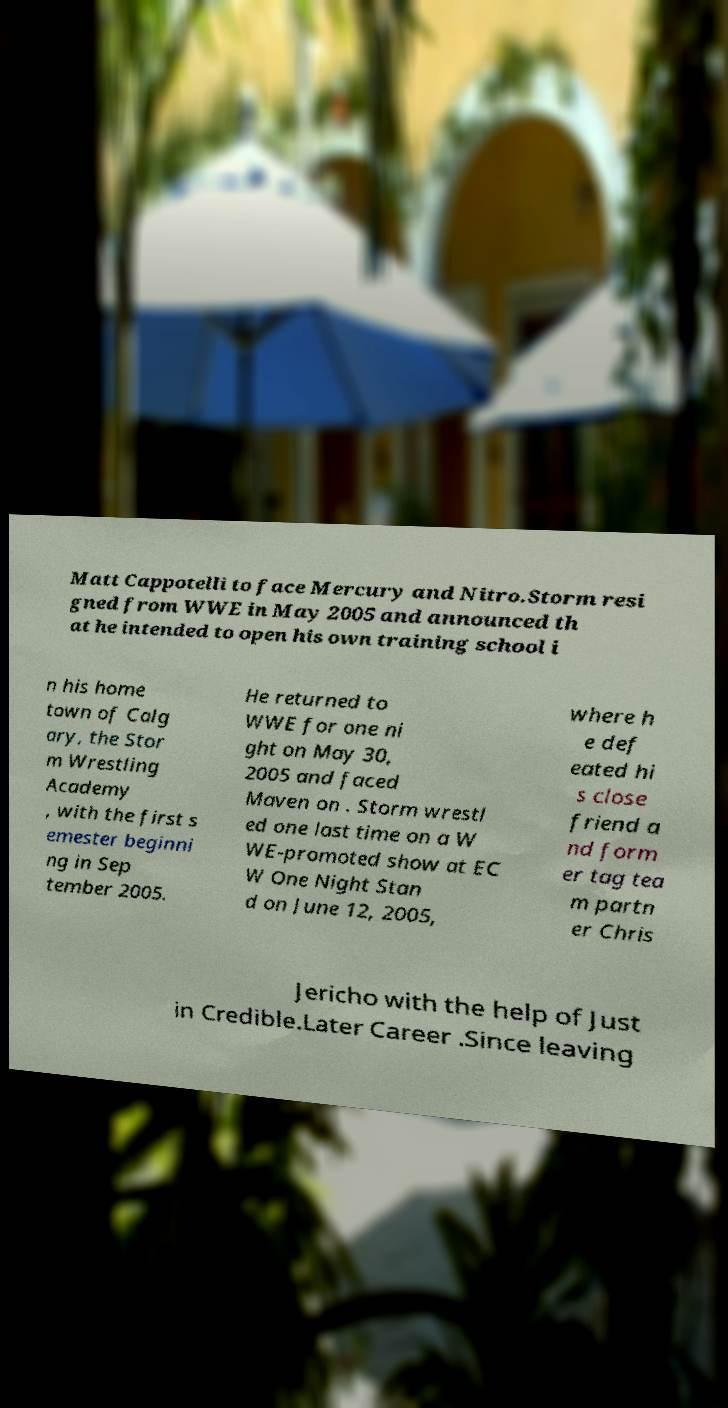Could you extract and type out the text from this image? Matt Cappotelli to face Mercury and Nitro.Storm resi gned from WWE in May 2005 and announced th at he intended to open his own training school i n his home town of Calg ary, the Stor m Wrestling Academy , with the first s emester beginni ng in Sep tember 2005. He returned to WWE for one ni ght on May 30, 2005 and faced Maven on . Storm wrestl ed one last time on a W WE-promoted show at EC W One Night Stan d on June 12, 2005, where h e def eated hi s close friend a nd form er tag tea m partn er Chris Jericho with the help of Just in Credible.Later Career .Since leaving 